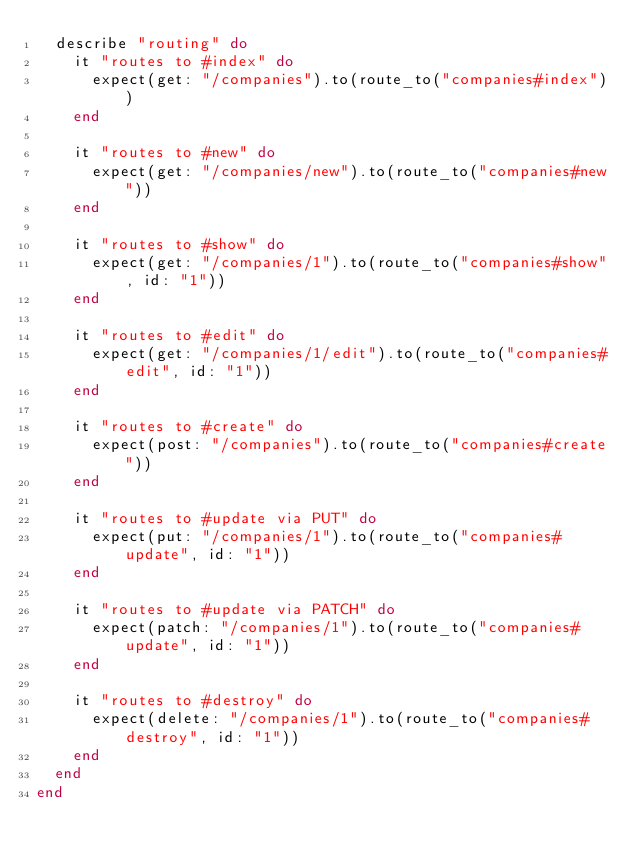Convert code to text. <code><loc_0><loc_0><loc_500><loc_500><_Ruby_>  describe "routing" do
    it "routes to #index" do
      expect(get: "/companies").to(route_to("companies#index"))
    end

    it "routes to #new" do
      expect(get: "/companies/new").to(route_to("companies#new"))
    end

    it "routes to #show" do
      expect(get: "/companies/1").to(route_to("companies#show", id: "1"))
    end

    it "routes to #edit" do
      expect(get: "/companies/1/edit").to(route_to("companies#edit", id: "1"))
    end

    it "routes to #create" do
      expect(post: "/companies").to(route_to("companies#create"))
    end

    it "routes to #update via PUT" do
      expect(put: "/companies/1").to(route_to("companies#update", id: "1"))
    end

    it "routes to #update via PATCH" do
      expect(patch: "/companies/1").to(route_to("companies#update", id: "1"))
    end

    it "routes to #destroy" do
      expect(delete: "/companies/1").to(route_to("companies#destroy", id: "1"))
    end
  end
end
</code> 